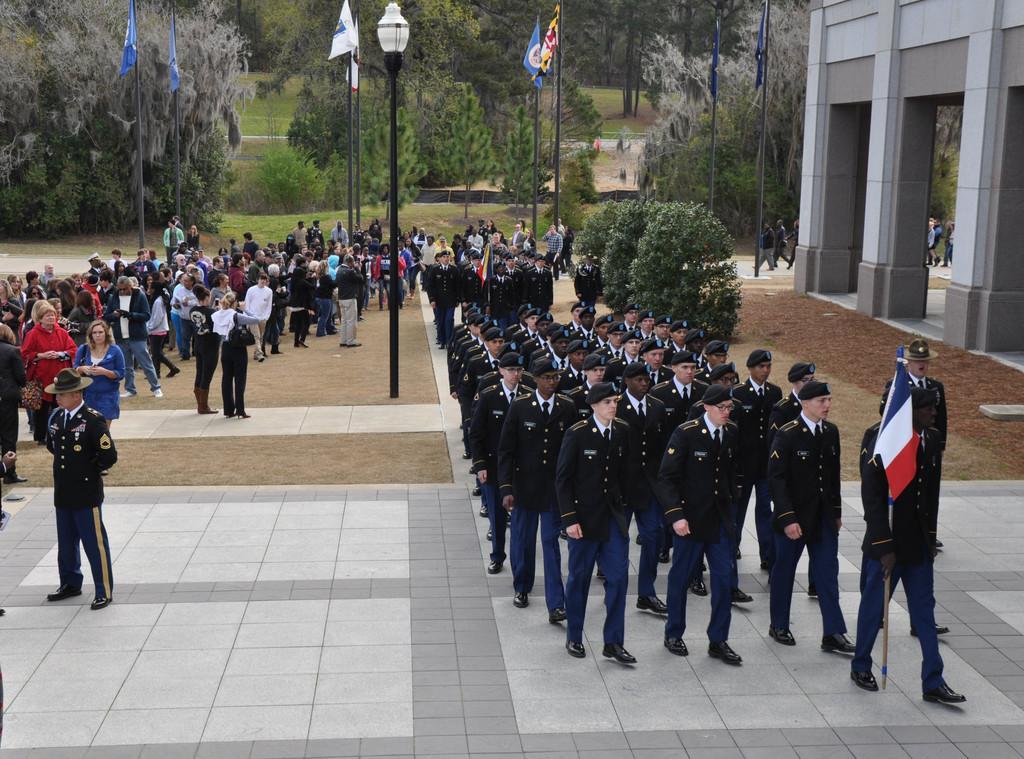Can you describe this image briefly? In this picture there is a building. There are group of people walking. In the foreground there is a man holding the flag and walking. At the back there are trees and flags and there is a light pole. At the bottom there is grass and there is ground and there is a floor. 